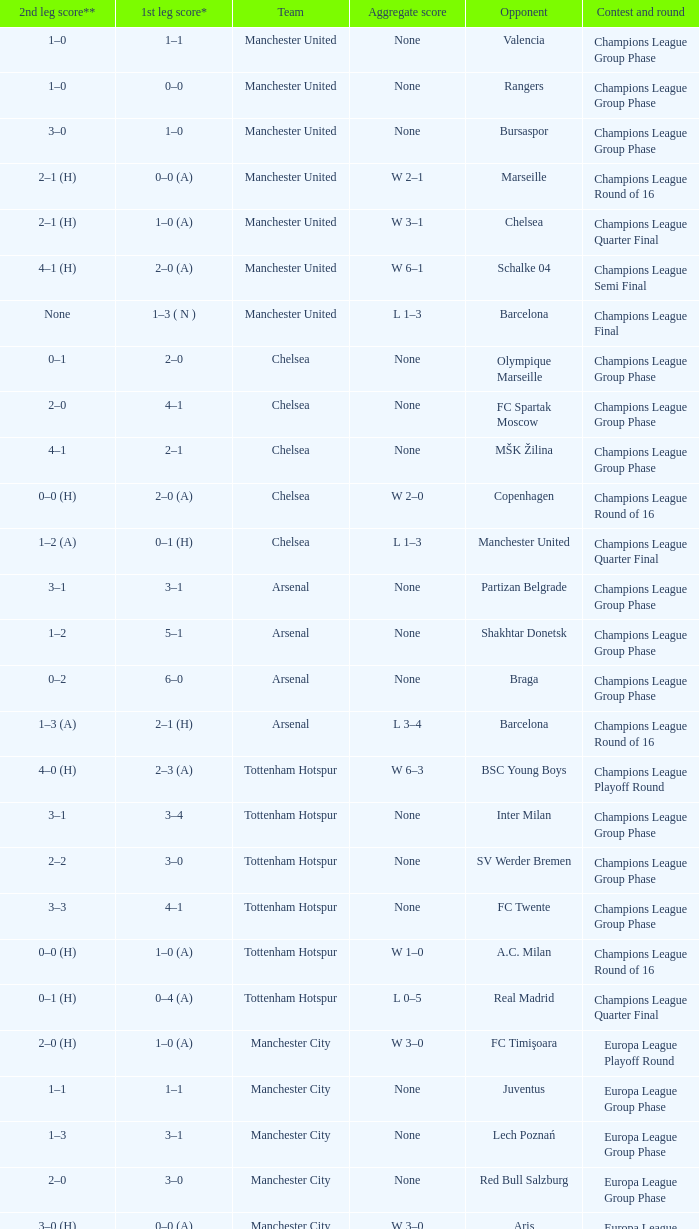Would you mind parsing the complete table? {'header': ['2nd leg score**', '1st leg score*', 'Team', 'Aggregate score', 'Opponent', 'Contest and round'], 'rows': [['1–0', '1–1', 'Manchester United', 'None', 'Valencia', 'Champions League Group Phase'], ['1–0', '0–0', 'Manchester United', 'None', 'Rangers', 'Champions League Group Phase'], ['3–0', '1–0', 'Manchester United', 'None', 'Bursaspor', 'Champions League Group Phase'], ['2–1 (H)', '0–0 (A)', 'Manchester United', 'W 2–1', 'Marseille', 'Champions League Round of 16'], ['2–1 (H)', '1–0 (A)', 'Manchester United', 'W 3–1', 'Chelsea', 'Champions League Quarter Final'], ['4–1 (H)', '2–0 (A)', 'Manchester United', 'W 6–1', 'Schalke 04', 'Champions League Semi Final'], ['None', '1–3 ( N )', 'Manchester United', 'L 1–3', 'Barcelona', 'Champions League Final'], ['0–1', '2–0', 'Chelsea', 'None', 'Olympique Marseille', 'Champions League Group Phase'], ['2–0', '4–1', 'Chelsea', 'None', 'FC Spartak Moscow', 'Champions League Group Phase'], ['4–1', '2–1', 'Chelsea', 'None', 'MŠK Žilina', 'Champions League Group Phase'], ['0–0 (H)', '2–0 (A)', 'Chelsea', 'W 2–0', 'Copenhagen', 'Champions League Round of 16'], ['1–2 (A)', '0–1 (H)', 'Chelsea', 'L 1–3', 'Manchester United', 'Champions League Quarter Final'], ['3–1', '3–1', 'Arsenal', 'None', 'Partizan Belgrade', 'Champions League Group Phase'], ['1–2', '5–1', 'Arsenal', 'None', 'Shakhtar Donetsk', 'Champions League Group Phase'], ['0–2', '6–0', 'Arsenal', 'None', 'Braga', 'Champions League Group Phase'], ['1–3 (A)', '2–1 (H)', 'Arsenal', 'L 3–4', 'Barcelona', 'Champions League Round of 16'], ['4–0 (H)', '2–3 (A)', 'Tottenham Hotspur', 'W 6–3', 'BSC Young Boys', 'Champions League Playoff Round'], ['3–1', '3–4', 'Tottenham Hotspur', 'None', 'Inter Milan', 'Champions League Group Phase'], ['2–2', '3–0', 'Tottenham Hotspur', 'None', 'SV Werder Bremen', 'Champions League Group Phase'], ['3–3', '4–1', 'Tottenham Hotspur', 'None', 'FC Twente', 'Champions League Group Phase'], ['0–0 (H)', '1–0 (A)', 'Tottenham Hotspur', 'W 1–0', 'A.C. Milan', 'Champions League Round of 16'], ['0–1 (H)', '0–4 (A)', 'Tottenham Hotspur', 'L 0–5', 'Real Madrid', 'Champions League Quarter Final'], ['2–0 (H)', '1–0 (A)', 'Manchester City', 'W 3–0', 'FC Timişoara', 'Europa League Playoff Round'], ['1–1', '1–1', 'Manchester City', 'None', 'Juventus', 'Europa League Group Phase'], ['1–3', '3–1', 'Manchester City', 'None', 'Lech Poznań', 'Europa League Group Phase'], ['2–0', '3–0', 'Manchester City', 'None', 'Red Bull Salzburg', 'Europa League Group Phase'], ['3–0 (H)', '0–0 (A)', 'Manchester City', 'W 3–0', 'Aris', 'Europa League Round of 32'], ['1–0 (H)', '0–2 (A)', 'Manchester City', 'L 1–2', 'Dynamio Kyiv', 'Europa League Round of 16'], ['2–3 (H)', '1–1 (A)', 'Aston Villa', 'L 3–4', 'SK Rapid Wien', 'Europa League Playoff Round'], ['2–0 (H)', '2–0 (A)', 'Liverpool', 'W 4–0', 'FK Rabotnički', 'Europa League 3rd Qual. Round'], ['2–1 (A)', '1–0 (H)', 'Liverpool', 'W 3–1', 'Trabzonspor', 'Europa League Playoff Round'], ['0–0', '3–1', 'Liverpool', 'None', 'Napoli', 'Europa League Group Phase'], ['1–1', '4–1', 'Liverpool', 'None', 'Steaua Bucureşti', 'Europa League Group Phase'], ['0–0', '0–0', 'Liverpool', 'None', 'Utrecht', 'Europa League Group Phase'], ['1–0 (H)', '0–0 (A)', 'Liverpool', 'W 1–0', 'Sparta Prague', 'Europa League Round of 32']]} In the initial leg of the liverpool versus trabzonspor match, what was the goal count for each team? 1–0 (H). 